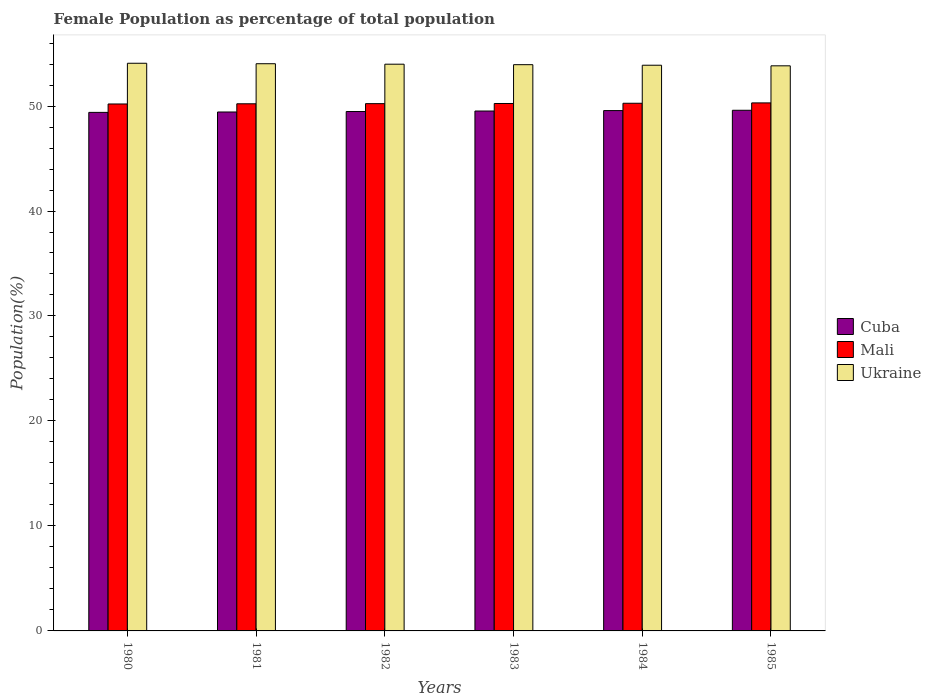Are the number of bars per tick equal to the number of legend labels?
Provide a short and direct response. Yes. What is the label of the 3rd group of bars from the left?
Give a very brief answer. 1982. What is the female population in in Cuba in 1983?
Keep it short and to the point. 49.52. Across all years, what is the maximum female population in in Mali?
Make the answer very short. 50.3. Across all years, what is the minimum female population in in Ukraine?
Keep it short and to the point. 53.83. In which year was the female population in in Cuba maximum?
Keep it short and to the point. 1985. In which year was the female population in in Mali minimum?
Offer a terse response. 1980. What is the total female population in in Mali in the graph?
Your response must be concise. 301.44. What is the difference between the female population in in Cuba in 1984 and that in 1985?
Your response must be concise. -0.03. What is the difference between the female population in in Ukraine in 1981 and the female population in in Mali in 1982?
Your response must be concise. 3.8. What is the average female population in in Ukraine per year?
Your answer should be compact. 53.96. In the year 1981, what is the difference between the female population in in Ukraine and female population in in Mali?
Offer a very short reply. 3.82. In how many years, is the female population in in Ukraine greater than 6 %?
Ensure brevity in your answer.  6. What is the ratio of the female population in in Mali in 1984 to that in 1985?
Keep it short and to the point. 1. Is the difference between the female population in in Ukraine in 1981 and 1984 greater than the difference between the female population in in Mali in 1981 and 1984?
Offer a terse response. Yes. What is the difference between the highest and the second highest female population in in Cuba?
Give a very brief answer. 0.03. What is the difference between the highest and the lowest female population in in Mali?
Your response must be concise. 0.1. Is the sum of the female population in in Mali in 1980 and 1984 greater than the maximum female population in in Ukraine across all years?
Your answer should be very brief. Yes. What does the 1st bar from the left in 1981 represents?
Offer a terse response. Cuba. What does the 3rd bar from the right in 1984 represents?
Keep it short and to the point. Cuba. Are all the bars in the graph horizontal?
Offer a terse response. No. What is the difference between two consecutive major ticks on the Y-axis?
Your answer should be very brief. 10. Are the values on the major ticks of Y-axis written in scientific E-notation?
Your answer should be very brief. No. Does the graph contain any zero values?
Provide a short and direct response. No. Does the graph contain grids?
Your answer should be very brief. No. Where does the legend appear in the graph?
Provide a short and direct response. Center right. How many legend labels are there?
Provide a short and direct response. 3. What is the title of the graph?
Provide a short and direct response. Female Population as percentage of total population. What is the label or title of the X-axis?
Offer a very short reply. Years. What is the label or title of the Y-axis?
Your answer should be compact. Population(%). What is the Population(%) of Cuba in 1980?
Offer a terse response. 49.4. What is the Population(%) in Mali in 1980?
Give a very brief answer. 50.2. What is the Population(%) of Ukraine in 1980?
Provide a short and direct response. 54.07. What is the Population(%) in Cuba in 1981?
Keep it short and to the point. 49.43. What is the Population(%) in Mali in 1981?
Make the answer very short. 50.21. What is the Population(%) of Ukraine in 1981?
Offer a very short reply. 54.03. What is the Population(%) of Cuba in 1982?
Make the answer very short. 49.48. What is the Population(%) of Mali in 1982?
Ensure brevity in your answer.  50.23. What is the Population(%) in Ukraine in 1982?
Provide a succinct answer. 53.99. What is the Population(%) in Cuba in 1983?
Provide a short and direct response. 49.52. What is the Population(%) of Mali in 1983?
Provide a succinct answer. 50.24. What is the Population(%) in Ukraine in 1983?
Offer a terse response. 53.94. What is the Population(%) of Cuba in 1984?
Make the answer very short. 49.57. What is the Population(%) in Mali in 1984?
Ensure brevity in your answer.  50.26. What is the Population(%) of Ukraine in 1984?
Your response must be concise. 53.89. What is the Population(%) in Cuba in 1985?
Provide a succinct answer. 49.6. What is the Population(%) of Mali in 1985?
Your answer should be very brief. 50.3. What is the Population(%) in Ukraine in 1985?
Keep it short and to the point. 53.83. Across all years, what is the maximum Population(%) of Cuba?
Provide a short and direct response. 49.6. Across all years, what is the maximum Population(%) of Mali?
Keep it short and to the point. 50.3. Across all years, what is the maximum Population(%) in Ukraine?
Offer a terse response. 54.07. Across all years, what is the minimum Population(%) in Cuba?
Your answer should be compact. 49.4. Across all years, what is the minimum Population(%) in Mali?
Provide a succinct answer. 50.2. Across all years, what is the minimum Population(%) in Ukraine?
Offer a very short reply. 53.83. What is the total Population(%) of Cuba in the graph?
Ensure brevity in your answer.  296.99. What is the total Population(%) in Mali in the graph?
Offer a terse response. 301.44. What is the total Population(%) in Ukraine in the graph?
Offer a very short reply. 323.74. What is the difference between the Population(%) of Cuba in 1980 and that in 1981?
Ensure brevity in your answer.  -0.04. What is the difference between the Population(%) of Mali in 1980 and that in 1981?
Give a very brief answer. -0.02. What is the difference between the Population(%) in Ukraine in 1980 and that in 1981?
Make the answer very short. 0.04. What is the difference between the Population(%) in Cuba in 1980 and that in 1982?
Ensure brevity in your answer.  -0.08. What is the difference between the Population(%) in Mali in 1980 and that in 1982?
Your answer should be very brief. -0.03. What is the difference between the Population(%) of Ukraine in 1980 and that in 1982?
Provide a succinct answer. 0.09. What is the difference between the Population(%) in Cuba in 1980 and that in 1983?
Provide a succinct answer. -0.13. What is the difference between the Population(%) in Mali in 1980 and that in 1983?
Provide a succinct answer. -0.05. What is the difference between the Population(%) in Ukraine in 1980 and that in 1983?
Ensure brevity in your answer.  0.14. What is the difference between the Population(%) of Cuba in 1980 and that in 1984?
Provide a short and direct response. -0.17. What is the difference between the Population(%) of Mali in 1980 and that in 1984?
Your answer should be compact. -0.07. What is the difference between the Population(%) in Ukraine in 1980 and that in 1984?
Offer a very short reply. 0.19. What is the difference between the Population(%) in Cuba in 1980 and that in 1985?
Your answer should be compact. -0.2. What is the difference between the Population(%) in Mali in 1980 and that in 1985?
Give a very brief answer. -0.1. What is the difference between the Population(%) in Ukraine in 1980 and that in 1985?
Offer a very short reply. 0.24. What is the difference between the Population(%) in Cuba in 1981 and that in 1982?
Your answer should be very brief. -0.04. What is the difference between the Population(%) in Mali in 1981 and that in 1982?
Provide a succinct answer. -0.01. What is the difference between the Population(%) of Ukraine in 1981 and that in 1982?
Make the answer very short. 0.04. What is the difference between the Population(%) of Cuba in 1981 and that in 1983?
Provide a short and direct response. -0.09. What is the difference between the Population(%) of Mali in 1981 and that in 1983?
Your answer should be very brief. -0.03. What is the difference between the Population(%) of Ukraine in 1981 and that in 1983?
Ensure brevity in your answer.  0.09. What is the difference between the Population(%) in Cuba in 1981 and that in 1984?
Ensure brevity in your answer.  -0.13. What is the difference between the Population(%) in Mali in 1981 and that in 1984?
Ensure brevity in your answer.  -0.05. What is the difference between the Population(%) of Ukraine in 1981 and that in 1984?
Your answer should be very brief. 0.14. What is the difference between the Population(%) in Cuba in 1981 and that in 1985?
Give a very brief answer. -0.16. What is the difference between the Population(%) of Mali in 1981 and that in 1985?
Ensure brevity in your answer.  -0.08. What is the difference between the Population(%) in Ukraine in 1981 and that in 1985?
Give a very brief answer. 0.2. What is the difference between the Population(%) in Cuba in 1982 and that in 1983?
Provide a succinct answer. -0.05. What is the difference between the Population(%) of Mali in 1982 and that in 1983?
Keep it short and to the point. -0.01. What is the difference between the Population(%) of Ukraine in 1982 and that in 1983?
Keep it short and to the point. 0.05. What is the difference between the Population(%) of Cuba in 1982 and that in 1984?
Provide a succinct answer. -0.09. What is the difference between the Population(%) in Mali in 1982 and that in 1984?
Keep it short and to the point. -0.04. What is the difference between the Population(%) of Ukraine in 1982 and that in 1984?
Your response must be concise. 0.1. What is the difference between the Population(%) in Cuba in 1982 and that in 1985?
Offer a very short reply. -0.12. What is the difference between the Population(%) in Mali in 1982 and that in 1985?
Keep it short and to the point. -0.07. What is the difference between the Population(%) of Ukraine in 1982 and that in 1985?
Your answer should be very brief. 0.16. What is the difference between the Population(%) of Cuba in 1983 and that in 1984?
Provide a short and direct response. -0.04. What is the difference between the Population(%) of Mali in 1983 and that in 1984?
Provide a short and direct response. -0.02. What is the difference between the Population(%) of Ukraine in 1983 and that in 1984?
Provide a short and direct response. 0.05. What is the difference between the Population(%) of Cuba in 1983 and that in 1985?
Your response must be concise. -0.07. What is the difference between the Population(%) of Mali in 1983 and that in 1985?
Make the answer very short. -0.06. What is the difference between the Population(%) in Ukraine in 1983 and that in 1985?
Your answer should be compact. 0.11. What is the difference between the Population(%) in Cuba in 1984 and that in 1985?
Make the answer very short. -0.03. What is the difference between the Population(%) in Mali in 1984 and that in 1985?
Give a very brief answer. -0.03. What is the difference between the Population(%) of Ukraine in 1984 and that in 1985?
Offer a very short reply. 0.06. What is the difference between the Population(%) in Cuba in 1980 and the Population(%) in Mali in 1981?
Provide a short and direct response. -0.82. What is the difference between the Population(%) in Cuba in 1980 and the Population(%) in Ukraine in 1981?
Provide a short and direct response. -4.63. What is the difference between the Population(%) of Mali in 1980 and the Population(%) of Ukraine in 1981?
Offer a very short reply. -3.83. What is the difference between the Population(%) of Cuba in 1980 and the Population(%) of Mali in 1982?
Provide a succinct answer. -0.83. What is the difference between the Population(%) in Cuba in 1980 and the Population(%) in Ukraine in 1982?
Your response must be concise. -4.59. What is the difference between the Population(%) of Mali in 1980 and the Population(%) of Ukraine in 1982?
Offer a terse response. -3.79. What is the difference between the Population(%) in Cuba in 1980 and the Population(%) in Mali in 1983?
Your answer should be very brief. -0.85. What is the difference between the Population(%) of Cuba in 1980 and the Population(%) of Ukraine in 1983?
Provide a succinct answer. -4.54. What is the difference between the Population(%) of Mali in 1980 and the Population(%) of Ukraine in 1983?
Make the answer very short. -3.74. What is the difference between the Population(%) of Cuba in 1980 and the Population(%) of Mali in 1984?
Ensure brevity in your answer.  -0.87. What is the difference between the Population(%) of Cuba in 1980 and the Population(%) of Ukraine in 1984?
Your answer should be compact. -4.49. What is the difference between the Population(%) in Mali in 1980 and the Population(%) in Ukraine in 1984?
Provide a short and direct response. -3.69. What is the difference between the Population(%) in Cuba in 1980 and the Population(%) in Mali in 1985?
Keep it short and to the point. -0.9. What is the difference between the Population(%) of Cuba in 1980 and the Population(%) of Ukraine in 1985?
Your answer should be compact. -4.43. What is the difference between the Population(%) in Mali in 1980 and the Population(%) in Ukraine in 1985?
Your answer should be compact. -3.63. What is the difference between the Population(%) of Cuba in 1981 and the Population(%) of Mali in 1982?
Keep it short and to the point. -0.79. What is the difference between the Population(%) of Cuba in 1981 and the Population(%) of Ukraine in 1982?
Offer a very short reply. -4.55. What is the difference between the Population(%) of Mali in 1981 and the Population(%) of Ukraine in 1982?
Give a very brief answer. -3.77. What is the difference between the Population(%) in Cuba in 1981 and the Population(%) in Mali in 1983?
Offer a very short reply. -0.81. What is the difference between the Population(%) in Cuba in 1981 and the Population(%) in Ukraine in 1983?
Offer a terse response. -4.51. What is the difference between the Population(%) of Mali in 1981 and the Population(%) of Ukraine in 1983?
Offer a very short reply. -3.73. What is the difference between the Population(%) in Cuba in 1981 and the Population(%) in Mali in 1984?
Provide a succinct answer. -0.83. What is the difference between the Population(%) of Cuba in 1981 and the Population(%) of Ukraine in 1984?
Provide a short and direct response. -4.46. What is the difference between the Population(%) of Mali in 1981 and the Population(%) of Ukraine in 1984?
Give a very brief answer. -3.67. What is the difference between the Population(%) of Cuba in 1981 and the Population(%) of Mali in 1985?
Offer a terse response. -0.87. What is the difference between the Population(%) in Cuba in 1981 and the Population(%) in Ukraine in 1985?
Offer a very short reply. -4.4. What is the difference between the Population(%) of Mali in 1981 and the Population(%) of Ukraine in 1985?
Provide a short and direct response. -3.62. What is the difference between the Population(%) of Cuba in 1982 and the Population(%) of Mali in 1983?
Offer a terse response. -0.76. What is the difference between the Population(%) in Cuba in 1982 and the Population(%) in Ukraine in 1983?
Offer a very short reply. -4.46. What is the difference between the Population(%) of Mali in 1982 and the Population(%) of Ukraine in 1983?
Offer a very short reply. -3.71. What is the difference between the Population(%) in Cuba in 1982 and the Population(%) in Mali in 1984?
Your answer should be very brief. -0.79. What is the difference between the Population(%) in Cuba in 1982 and the Population(%) in Ukraine in 1984?
Offer a terse response. -4.41. What is the difference between the Population(%) of Mali in 1982 and the Population(%) of Ukraine in 1984?
Provide a short and direct response. -3.66. What is the difference between the Population(%) of Cuba in 1982 and the Population(%) of Mali in 1985?
Ensure brevity in your answer.  -0.82. What is the difference between the Population(%) of Cuba in 1982 and the Population(%) of Ukraine in 1985?
Make the answer very short. -4.35. What is the difference between the Population(%) in Mali in 1982 and the Population(%) in Ukraine in 1985?
Provide a succinct answer. -3.6. What is the difference between the Population(%) of Cuba in 1983 and the Population(%) of Mali in 1984?
Keep it short and to the point. -0.74. What is the difference between the Population(%) in Cuba in 1983 and the Population(%) in Ukraine in 1984?
Offer a terse response. -4.36. What is the difference between the Population(%) in Mali in 1983 and the Population(%) in Ukraine in 1984?
Offer a very short reply. -3.65. What is the difference between the Population(%) in Cuba in 1983 and the Population(%) in Mali in 1985?
Your answer should be very brief. -0.77. What is the difference between the Population(%) of Cuba in 1983 and the Population(%) of Ukraine in 1985?
Make the answer very short. -4.31. What is the difference between the Population(%) in Mali in 1983 and the Population(%) in Ukraine in 1985?
Your answer should be compact. -3.59. What is the difference between the Population(%) in Cuba in 1984 and the Population(%) in Mali in 1985?
Offer a terse response. -0.73. What is the difference between the Population(%) of Cuba in 1984 and the Population(%) of Ukraine in 1985?
Provide a succinct answer. -4.26. What is the difference between the Population(%) of Mali in 1984 and the Population(%) of Ukraine in 1985?
Your response must be concise. -3.57. What is the average Population(%) of Cuba per year?
Your answer should be compact. 49.5. What is the average Population(%) of Mali per year?
Your answer should be very brief. 50.24. What is the average Population(%) of Ukraine per year?
Your answer should be compact. 53.96. In the year 1980, what is the difference between the Population(%) in Cuba and Population(%) in Mali?
Offer a very short reply. -0.8. In the year 1980, what is the difference between the Population(%) in Cuba and Population(%) in Ukraine?
Offer a very short reply. -4.68. In the year 1980, what is the difference between the Population(%) of Mali and Population(%) of Ukraine?
Give a very brief answer. -3.88. In the year 1981, what is the difference between the Population(%) of Cuba and Population(%) of Mali?
Offer a very short reply. -0.78. In the year 1981, what is the difference between the Population(%) of Cuba and Population(%) of Ukraine?
Offer a terse response. -4.6. In the year 1981, what is the difference between the Population(%) of Mali and Population(%) of Ukraine?
Offer a very short reply. -3.82. In the year 1982, what is the difference between the Population(%) of Cuba and Population(%) of Mali?
Your response must be concise. -0.75. In the year 1982, what is the difference between the Population(%) in Cuba and Population(%) in Ukraine?
Give a very brief answer. -4.51. In the year 1982, what is the difference between the Population(%) of Mali and Population(%) of Ukraine?
Offer a terse response. -3.76. In the year 1983, what is the difference between the Population(%) in Cuba and Population(%) in Mali?
Your answer should be very brief. -0.72. In the year 1983, what is the difference between the Population(%) of Cuba and Population(%) of Ukraine?
Offer a terse response. -4.41. In the year 1983, what is the difference between the Population(%) in Mali and Population(%) in Ukraine?
Make the answer very short. -3.7. In the year 1984, what is the difference between the Population(%) in Cuba and Population(%) in Mali?
Your response must be concise. -0.7. In the year 1984, what is the difference between the Population(%) of Cuba and Population(%) of Ukraine?
Offer a very short reply. -4.32. In the year 1984, what is the difference between the Population(%) in Mali and Population(%) in Ukraine?
Your answer should be very brief. -3.62. In the year 1985, what is the difference between the Population(%) in Cuba and Population(%) in Mali?
Provide a succinct answer. -0.7. In the year 1985, what is the difference between the Population(%) of Cuba and Population(%) of Ukraine?
Your answer should be compact. -4.23. In the year 1985, what is the difference between the Population(%) of Mali and Population(%) of Ukraine?
Your response must be concise. -3.53. What is the ratio of the Population(%) of Cuba in 1980 to that in 1982?
Offer a very short reply. 1. What is the ratio of the Population(%) in Mali in 1980 to that in 1982?
Offer a terse response. 1. What is the ratio of the Population(%) of Cuba in 1980 to that in 1983?
Offer a terse response. 1. What is the ratio of the Population(%) in Mali in 1980 to that in 1983?
Ensure brevity in your answer.  1. What is the ratio of the Population(%) in Ukraine in 1980 to that in 1983?
Provide a short and direct response. 1. What is the ratio of the Population(%) in Cuba in 1980 to that in 1984?
Your answer should be very brief. 1. What is the ratio of the Population(%) in Mali in 1980 to that in 1984?
Your answer should be compact. 1. What is the ratio of the Population(%) of Ukraine in 1980 to that in 1984?
Your answer should be very brief. 1. What is the ratio of the Population(%) in Mali in 1980 to that in 1985?
Ensure brevity in your answer.  1. What is the ratio of the Population(%) of Ukraine in 1980 to that in 1985?
Your answer should be compact. 1. What is the ratio of the Population(%) of Ukraine in 1981 to that in 1982?
Your answer should be very brief. 1. What is the ratio of the Population(%) in Mali in 1981 to that in 1984?
Your response must be concise. 1. What is the ratio of the Population(%) in Ukraine in 1981 to that in 1984?
Offer a terse response. 1. What is the ratio of the Population(%) of Cuba in 1982 to that in 1983?
Make the answer very short. 1. What is the ratio of the Population(%) of Ukraine in 1982 to that in 1983?
Keep it short and to the point. 1. What is the ratio of the Population(%) in Mali in 1982 to that in 1984?
Your answer should be very brief. 1. What is the ratio of the Population(%) in Ukraine in 1982 to that in 1984?
Provide a short and direct response. 1. What is the ratio of the Population(%) of Cuba in 1982 to that in 1985?
Your response must be concise. 1. What is the ratio of the Population(%) in Mali in 1983 to that in 1985?
Your response must be concise. 1. What is the ratio of the Population(%) of Ukraine in 1983 to that in 1985?
Provide a short and direct response. 1. What is the ratio of the Population(%) in Mali in 1984 to that in 1985?
Ensure brevity in your answer.  1. What is the ratio of the Population(%) in Ukraine in 1984 to that in 1985?
Keep it short and to the point. 1. What is the difference between the highest and the second highest Population(%) of Cuba?
Your response must be concise. 0.03. What is the difference between the highest and the second highest Population(%) of Mali?
Offer a very short reply. 0.03. What is the difference between the highest and the second highest Population(%) in Ukraine?
Your answer should be very brief. 0.04. What is the difference between the highest and the lowest Population(%) in Cuba?
Keep it short and to the point. 0.2. What is the difference between the highest and the lowest Population(%) in Mali?
Provide a short and direct response. 0.1. What is the difference between the highest and the lowest Population(%) in Ukraine?
Your response must be concise. 0.24. 